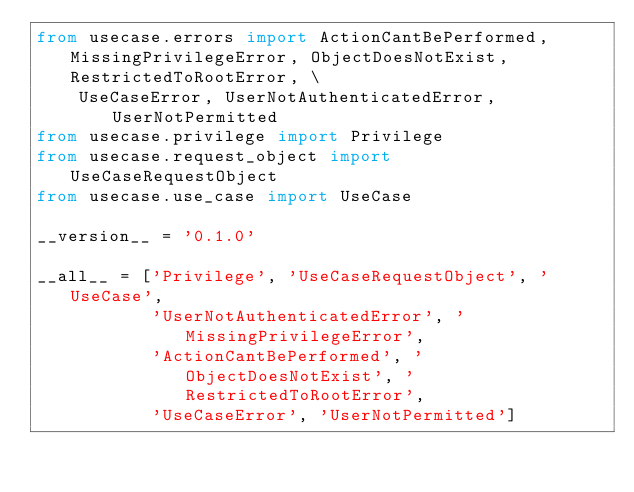Convert code to text. <code><loc_0><loc_0><loc_500><loc_500><_Python_>from usecase.errors import ActionCantBePerformed, MissingPrivilegeError, ObjectDoesNotExist, RestrictedToRootError, \
    UseCaseError, UserNotAuthenticatedError, UserNotPermitted
from usecase.privilege import Privilege
from usecase.request_object import UseCaseRequestObject
from usecase.use_case import UseCase

__version__ = '0.1.0'

__all__ = ['Privilege', 'UseCaseRequestObject', 'UseCase',
           'UserNotAuthenticatedError', 'MissingPrivilegeError',
           'ActionCantBePerformed', 'ObjectDoesNotExist', 'RestrictedToRootError',
           'UseCaseError', 'UserNotPermitted']
</code> 